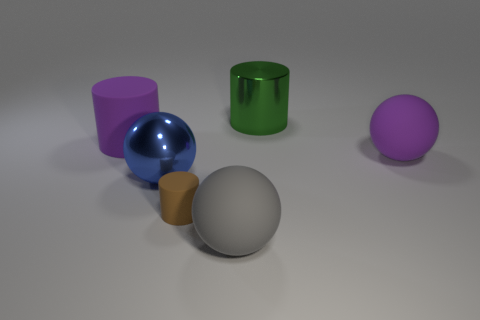Add 3 large purple cylinders. How many objects exist? 9 Add 3 big purple cylinders. How many big purple cylinders are left? 4 Add 1 big purple rubber spheres. How many big purple rubber spheres exist? 2 Subtract 0 gray cylinders. How many objects are left? 6 Subtract all large cyan metallic balls. Subtract all blue things. How many objects are left? 5 